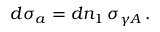<formula> <loc_0><loc_0><loc_500><loc_500>d \sigma _ { a } = d n _ { 1 } \, \sigma _ { \gamma A } \, .</formula> 